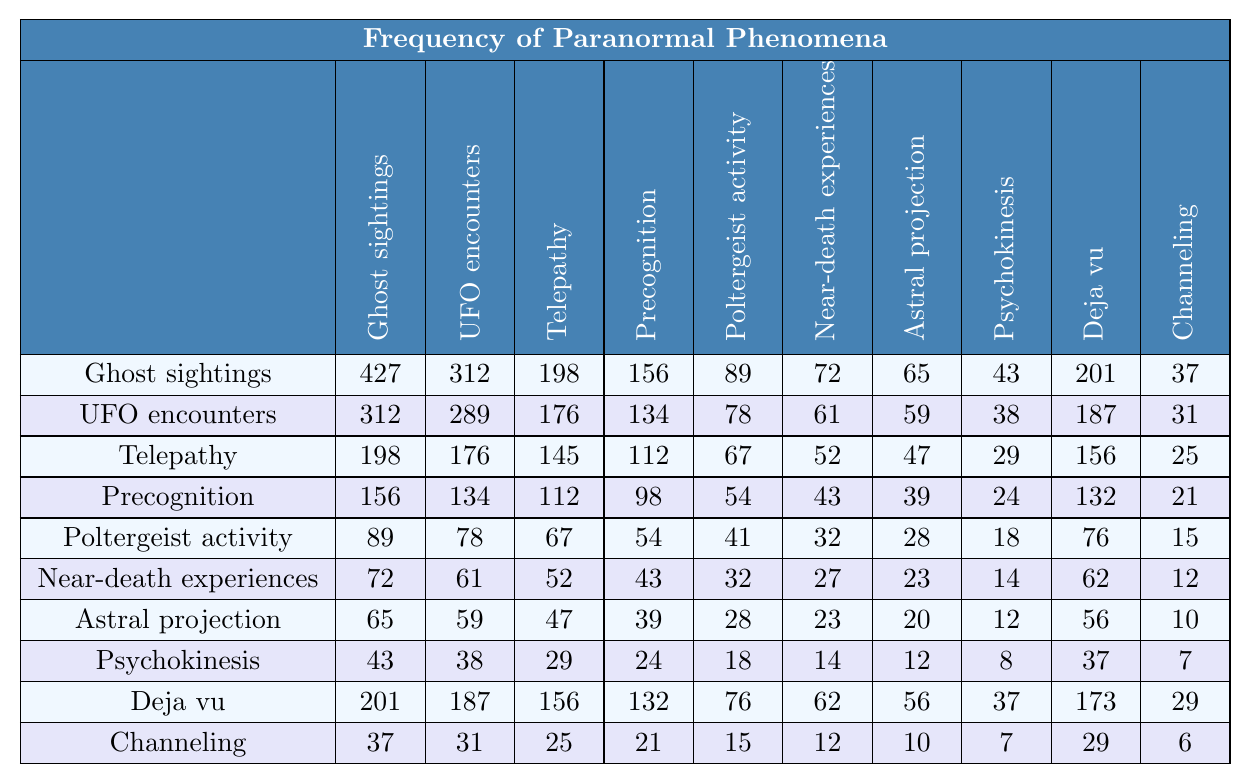What is the frequency of ghost sightings? The table lists ghost sightings at the top left corner, where the frequency value is recorded as 427.
Answer: 427 Which phenomenon has the lowest recorded frequency? From the last row of the table, channeling has the lowest value of 6.
Answer: 6 What is the frequency of near-death experiences compared to poltergeist activity? Near-death experiences have a frequency of 72, while poltergeist activity has a frequency of 89, indicating that poltergeist activity is more frequent.
Answer: 89 is higher than 72 What is the difference between the frequencies of UFO encounters and telepathy? The frequency of UFO encounters is 289, and telepathy is 145. The difference is 289 - 145 = 144.
Answer: 144 What is the average frequency of all phenomena listed? To calculate the average, sum all the frequencies (427 + 312 + 198 + 156 + 89 + 72 + 65 + 43 + 201 + 37 = 1600) and divide by the number of phenomena (10). So, 1600 / 10 = 160.
Answer: 160 Does psychokinesis have a higher frequency than deja vu? The frequency of psychokinesis is 43, while deja vu has a frequency of 201, therefore, psychokinesis has a lower frequency.
Answer: No Which phenomena has a higher frequency: UFO encounters or near-death experiences? UFO encounters have a frequency of 289, while near-death experiences have a frequency of 72. Thus, UFO encounters are more frequent.
Answer: UFO encounters What is the sum of the frequencies of telepathy and precognition? The frequency of telepathy is 145, and for precognition, it is 112. Adding these gives: 145 + 112 = 257.
Answer: 257 Which phenomenon has a frequency greater than 200? The phenomena with frequencies greater than 200 are ghost sightings (427), UFO encounters (289), and deja vu (201) as shown in the table.
Answer: Ghost sightings, UFO encounters, Deja vu What is the median frequency of all the phenomena? To find the median, list the frequencies in ascending order: [6, 7, 10, 12, 15, 18, 20, 23, 24, 25, 28, 29, 31, 32, 37, 39, 41, 43, 47, 52, 54, 56, 59, 61, 62, 65, 67, 72, 76, 78, 89, 98, 112, 134, 145, 156, 176, 187, 198, 201, 289, 427]. For 10 values, the median is the average of the 20th and 21st values (39 and 41), so (39 + 41)/2 = 40.
Answer: 40 